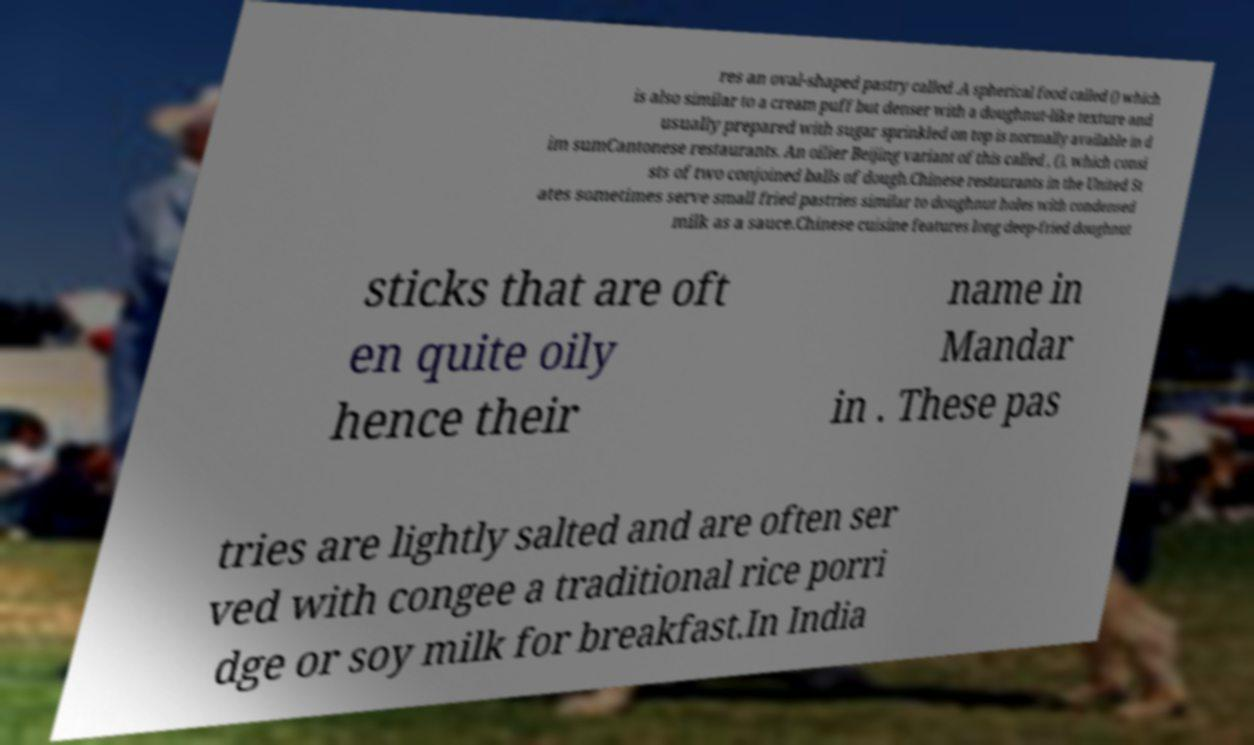Could you extract and type out the text from this image? res an oval-shaped pastry called .A spherical food called () which is also similar to a cream puff but denser with a doughnut-like texture and usually prepared with sugar sprinkled on top is normally available in d im sumCantonese restaurants. An oilier Beijing variant of this called , (), which consi sts of two conjoined balls of dough.Chinese restaurants in the United St ates sometimes serve small fried pastries similar to doughnut holes with condensed milk as a sauce.Chinese cuisine features long deep-fried doughnut sticks that are oft en quite oily hence their name in Mandar in . These pas tries are lightly salted and are often ser ved with congee a traditional rice porri dge or soy milk for breakfast.In India 